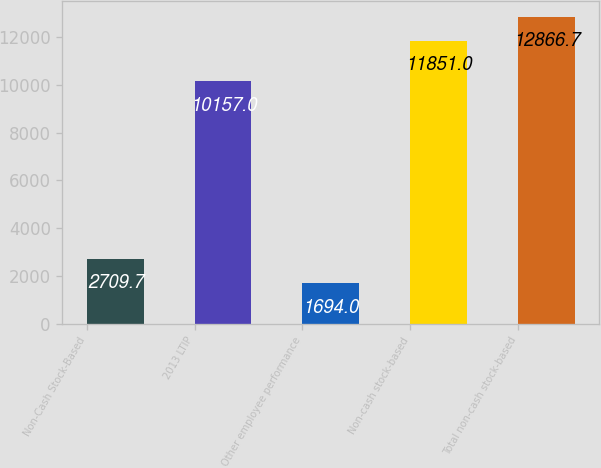Convert chart to OTSL. <chart><loc_0><loc_0><loc_500><loc_500><bar_chart><fcel>Non-Cash Stock-Based<fcel>2013 LTIP<fcel>Other employee performance<fcel>Non-cash stock-based<fcel>Total non-cash stock-based<nl><fcel>2709.7<fcel>10157<fcel>1694<fcel>11851<fcel>12866.7<nl></chart> 